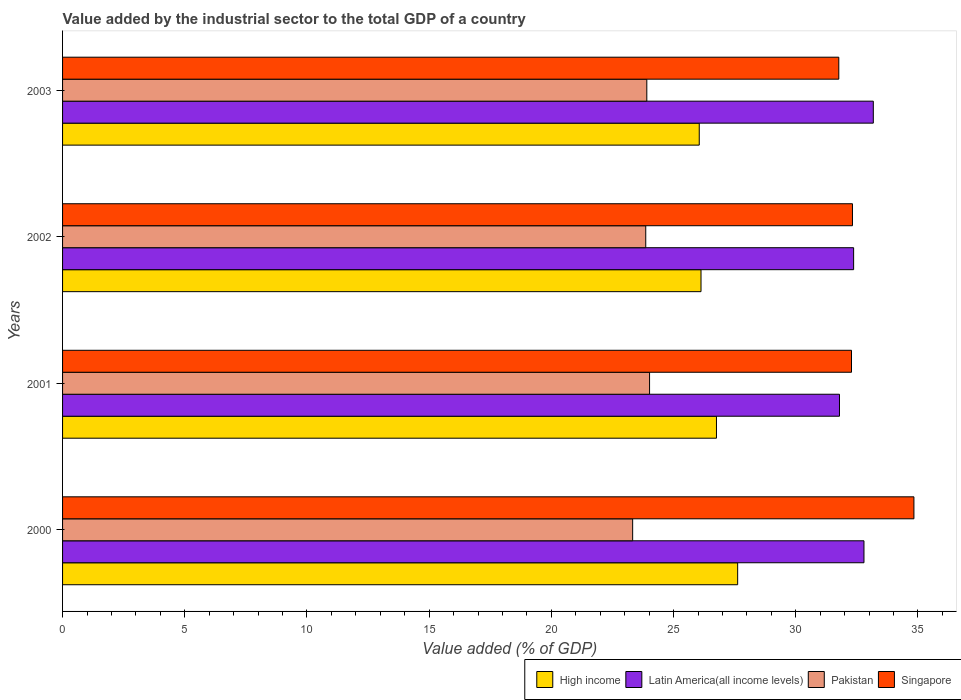How many different coloured bars are there?
Provide a short and direct response. 4. How many groups of bars are there?
Your answer should be compact. 4. Are the number of bars per tick equal to the number of legend labels?
Your answer should be compact. Yes. Are the number of bars on each tick of the Y-axis equal?
Provide a succinct answer. Yes. How many bars are there on the 4th tick from the top?
Offer a very short reply. 4. How many bars are there on the 3rd tick from the bottom?
Provide a short and direct response. 4. What is the label of the 2nd group of bars from the top?
Provide a succinct answer. 2002. What is the value added by the industrial sector to the total GDP in Latin America(all income levels) in 2002?
Ensure brevity in your answer.  32.37. Across all years, what is the maximum value added by the industrial sector to the total GDP in Pakistan?
Your answer should be compact. 24.02. Across all years, what is the minimum value added by the industrial sector to the total GDP in Latin America(all income levels)?
Your response must be concise. 31.79. In which year was the value added by the industrial sector to the total GDP in Singapore minimum?
Your answer should be very brief. 2003. What is the total value added by the industrial sector to the total GDP in Singapore in the graph?
Your answer should be very brief. 131.19. What is the difference between the value added by the industrial sector to the total GDP in Singapore in 2000 and that in 2003?
Make the answer very short. 3.07. What is the difference between the value added by the industrial sector to the total GDP in High income in 2000 and the value added by the industrial sector to the total GDP in Singapore in 2003?
Give a very brief answer. -4.14. What is the average value added by the industrial sector to the total GDP in Pakistan per year?
Give a very brief answer. 23.78. In the year 2003, what is the difference between the value added by the industrial sector to the total GDP in Singapore and value added by the industrial sector to the total GDP in Pakistan?
Your answer should be very brief. 7.86. What is the ratio of the value added by the industrial sector to the total GDP in Pakistan in 2000 to that in 2003?
Provide a short and direct response. 0.98. Is the difference between the value added by the industrial sector to the total GDP in Singapore in 2000 and 2002 greater than the difference between the value added by the industrial sector to the total GDP in Pakistan in 2000 and 2002?
Ensure brevity in your answer.  Yes. What is the difference between the highest and the second highest value added by the industrial sector to the total GDP in Pakistan?
Offer a terse response. 0.11. What is the difference between the highest and the lowest value added by the industrial sector to the total GDP in Singapore?
Your response must be concise. 3.07. Is the sum of the value added by the industrial sector to the total GDP in Pakistan in 2001 and 2002 greater than the maximum value added by the industrial sector to the total GDP in Latin America(all income levels) across all years?
Make the answer very short. Yes. What does the 2nd bar from the top in 2001 represents?
Provide a succinct answer. Pakistan. What does the 4th bar from the bottom in 2000 represents?
Ensure brevity in your answer.  Singapore. Is it the case that in every year, the sum of the value added by the industrial sector to the total GDP in Pakistan and value added by the industrial sector to the total GDP in High income is greater than the value added by the industrial sector to the total GDP in Singapore?
Provide a succinct answer. Yes. How many bars are there?
Ensure brevity in your answer.  16. Are all the bars in the graph horizontal?
Give a very brief answer. Yes. How many years are there in the graph?
Your response must be concise. 4. Where does the legend appear in the graph?
Your answer should be very brief. Bottom right. How many legend labels are there?
Offer a terse response. 4. What is the title of the graph?
Provide a short and direct response. Value added by the industrial sector to the total GDP of a country. Does "Austria" appear as one of the legend labels in the graph?
Offer a terse response. No. What is the label or title of the X-axis?
Provide a short and direct response. Value added (% of GDP). What is the Value added (% of GDP) in High income in 2000?
Offer a terse response. 27.62. What is the Value added (% of GDP) of Latin America(all income levels) in 2000?
Keep it short and to the point. 32.79. What is the Value added (% of GDP) of Pakistan in 2000?
Your response must be concise. 23.33. What is the Value added (% of GDP) of Singapore in 2000?
Ensure brevity in your answer.  34.83. What is the Value added (% of GDP) in High income in 2001?
Offer a terse response. 26.76. What is the Value added (% of GDP) in Latin America(all income levels) in 2001?
Offer a very short reply. 31.79. What is the Value added (% of GDP) of Pakistan in 2001?
Keep it short and to the point. 24.02. What is the Value added (% of GDP) of Singapore in 2001?
Provide a short and direct response. 32.28. What is the Value added (% of GDP) of High income in 2002?
Your answer should be compact. 26.12. What is the Value added (% of GDP) in Latin America(all income levels) in 2002?
Ensure brevity in your answer.  32.37. What is the Value added (% of GDP) in Pakistan in 2002?
Keep it short and to the point. 23.86. What is the Value added (% of GDP) of Singapore in 2002?
Your answer should be very brief. 32.32. What is the Value added (% of GDP) in High income in 2003?
Provide a short and direct response. 26.05. What is the Value added (% of GDP) in Latin America(all income levels) in 2003?
Your response must be concise. 33.17. What is the Value added (% of GDP) of Pakistan in 2003?
Give a very brief answer. 23.91. What is the Value added (% of GDP) of Singapore in 2003?
Your answer should be very brief. 31.76. Across all years, what is the maximum Value added (% of GDP) of High income?
Your response must be concise. 27.62. Across all years, what is the maximum Value added (% of GDP) of Latin America(all income levels)?
Your answer should be very brief. 33.17. Across all years, what is the maximum Value added (% of GDP) in Pakistan?
Provide a succinct answer. 24.02. Across all years, what is the maximum Value added (% of GDP) of Singapore?
Offer a terse response. 34.83. Across all years, what is the minimum Value added (% of GDP) in High income?
Keep it short and to the point. 26.05. Across all years, what is the minimum Value added (% of GDP) in Latin America(all income levels)?
Provide a succinct answer. 31.79. Across all years, what is the minimum Value added (% of GDP) of Pakistan?
Make the answer very short. 23.33. Across all years, what is the minimum Value added (% of GDP) in Singapore?
Your answer should be compact. 31.76. What is the total Value added (% of GDP) of High income in the graph?
Ensure brevity in your answer.  106.55. What is the total Value added (% of GDP) in Latin America(all income levels) in the graph?
Offer a terse response. 130.12. What is the total Value added (% of GDP) in Pakistan in the graph?
Make the answer very short. 95.11. What is the total Value added (% of GDP) of Singapore in the graph?
Offer a very short reply. 131.19. What is the difference between the Value added (% of GDP) of High income in 2000 and that in 2001?
Keep it short and to the point. 0.87. What is the difference between the Value added (% of GDP) of Pakistan in 2000 and that in 2001?
Your answer should be compact. -0.69. What is the difference between the Value added (% of GDP) in Singapore in 2000 and that in 2001?
Provide a succinct answer. 2.55. What is the difference between the Value added (% of GDP) of High income in 2000 and that in 2002?
Provide a short and direct response. 1.5. What is the difference between the Value added (% of GDP) of Latin America(all income levels) in 2000 and that in 2002?
Your answer should be very brief. 0.42. What is the difference between the Value added (% of GDP) of Pakistan in 2000 and that in 2002?
Provide a short and direct response. -0.54. What is the difference between the Value added (% of GDP) in Singapore in 2000 and that in 2002?
Ensure brevity in your answer.  2.51. What is the difference between the Value added (% of GDP) in High income in 2000 and that in 2003?
Keep it short and to the point. 1.57. What is the difference between the Value added (% of GDP) in Latin America(all income levels) in 2000 and that in 2003?
Your response must be concise. -0.38. What is the difference between the Value added (% of GDP) in Pakistan in 2000 and that in 2003?
Make the answer very short. -0.58. What is the difference between the Value added (% of GDP) in Singapore in 2000 and that in 2003?
Offer a terse response. 3.07. What is the difference between the Value added (% of GDP) of High income in 2001 and that in 2002?
Your answer should be compact. 0.63. What is the difference between the Value added (% of GDP) in Latin America(all income levels) in 2001 and that in 2002?
Give a very brief answer. -0.58. What is the difference between the Value added (% of GDP) in Pakistan in 2001 and that in 2002?
Your answer should be very brief. 0.16. What is the difference between the Value added (% of GDP) of Singapore in 2001 and that in 2002?
Your response must be concise. -0.04. What is the difference between the Value added (% of GDP) of High income in 2001 and that in 2003?
Offer a terse response. 0.7. What is the difference between the Value added (% of GDP) of Latin America(all income levels) in 2001 and that in 2003?
Ensure brevity in your answer.  -1.38. What is the difference between the Value added (% of GDP) of Pakistan in 2001 and that in 2003?
Your response must be concise. 0.11. What is the difference between the Value added (% of GDP) of Singapore in 2001 and that in 2003?
Offer a terse response. 0.52. What is the difference between the Value added (% of GDP) of High income in 2002 and that in 2003?
Provide a short and direct response. 0.07. What is the difference between the Value added (% of GDP) in Latin America(all income levels) in 2002 and that in 2003?
Make the answer very short. -0.81. What is the difference between the Value added (% of GDP) of Pakistan in 2002 and that in 2003?
Keep it short and to the point. -0.04. What is the difference between the Value added (% of GDP) of Singapore in 2002 and that in 2003?
Your answer should be very brief. 0.56. What is the difference between the Value added (% of GDP) in High income in 2000 and the Value added (% of GDP) in Latin America(all income levels) in 2001?
Offer a very short reply. -4.17. What is the difference between the Value added (% of GDP) in High income in 2000 and the Value added (% of GDP) in Pakistan in 2001?
Provide a succinct answer. 3.6. What is the difference between the Value added (% of GDP) in High income in 2000 and the Value added (% of GDP) in Singapore in 2001?
Your answer should be very brief. -4.66. What is the difference between the Value added (% of GDP) in Latin America(all income levels) in 2000 and the Value added (% of GDP) in Pakistan in 2001?
Give a very brief answer. 8.77. What is the difference between the Value added (% of GDP) of Latin America(all income levels) in 2000 and the Value added (% of GDP) of Singapore in 2001?
Provide a short and direct response. 0.51. What is the difference between the Value added (% of GDP) in Pakistan in 2000 and the Value added (% of GDP) in Singapore in 2001?
Your answer should be compact. -8.95. What is the difference between the Value added (% of GDP) in High income in 2000 and the Value added (% of GDP) in Latin America(all income levels) in 2002?
Your response must be concise. -4.75. What is the difference between the Value added (% of GDP) in High income in 2000 and the Value added (% of GDP) in Pakistan in 2002?
Offer a very short reply. 3.76. What is the difference between the Value added (% of GDP) in High income in 2000 and the Value added (% of GDP) in Singapore in 2002?
Provide a short and direct response. -4.7. What is the difference between the Value added (% of GDP) in Latin America(all income levels) in 2000 and the Value added (% of GDP) in Pakistan in 2002?
Ensure brevity in your answer.  8.93. What is the difference between the Value added (% of GDP) of Latin America(all income levels) in 2000 and the Value added (% of GDP) of Singapore in 2002?
Your answer should be compact. 0.47. What is the difference between the Value added (% of GDP) in Pakistan in 2000 and the Value added (% of GDP) in Singapore in 2002?
Offer a terse response. -8.99. What is the difference between the Value added (% of GDP) of High income in 2000 and the Value added (% of GDP) of Latin America(all income levels) in 2003?
Give a very brief answer. -5.55. What is the difference between the Value added (% of GDP) in High income in 2000 and the Value added (% of GDP) in Pakistan in 2003?
Offer a very short reply. 3.72. What is the difference between the Value added (% of GDP) of High income in 2000 and the Value added (% of GDP) of Singapore in 2003?
Your response must be concise. -4.14. What is the difference between the Value added (% of GDP) in Latin America(all income levels) in 2000 and the Value added (% of GDP) in Pakistan in 2003?
Your response must be concise. 8.88. What is the difference between the Value added (% of GDP) in Latin America(all income levels) in 2000 and the Value added (% of GDP) in Singapore in 2003?
Your answer should be compact. 1.03. What is the difference between the Value added (% of GDP) of Pakistan in 2000 and the Value added (% of GDP) of Singapore in 2003?
Offer a terse response. -8.43. What is the difference between the Value added (% of GDP) of High income in 2001 and the Value added (% of GDP) of Latin America(all income levels) in 2002?
Offer a terse response. -5.61. What is the difference between the Value added (% of GDP) of High income in 2001 and the Value added (% of GDP) of Pakistan in 2002?
Provide a succinct answer. 2.89. What is the difference between the Value added (% of GDP) of High income in 2001 and the Value added (% of GDP) of Singapore in 2002?
Make the answer very short. -5.56. What is the difference between the Value added (% of GDP) in Latin America(all income levels) in 2001 and the Value added (% of GDP) in Pakistan in 2002?
Offer a very short reply. 7.93. What is the difference between the Value added (% of GDP) in Latin America(all income levels) in 2001 and the Value added (% of GDP) in Singapore in 2002?
Keep it short and to the point. -0.53. What is the difference between the Value added (% of GDP) in Pakistan in 2001 and the Value added (% of GDP) in Singapore in 2002?
Provide a short and direct response. -8.3. What is the difference between the Value added (% of GDP) in High income in 2001 and the Value added (% of GDP) in Latin America(all income levels) in 2003?
Provide a succinct answer. -6.42. What is the difference between the Value added (% of GDP) in High income in 2001 and the Value added (% of GDP) in Pakistan in 2003?
Your answer should be very brief. 2.85. What is the difference between the Value added (% of GDP) of High income in 2001 and the Value added (% of GDP) of Singapore in 2003?
Give a very brief answer. -5.01. What is the difference between the Value added (% of GDP) in Latin America(all income levels) in 2001 and the Value added (% of GDP) in Pakistan in 2003?
Give a very brief answer. 7.88. What is the difference between the Value added (% of GDP) in Latin America(all income levels) in 2001 and the Value added (% of GDP) in Singapore in 2003?
Offer a terse response. 0.03. What is the difference between the Value added (% of GDP) of Pakistan in 2001 and the Value added (% of GDP) of Singapore in 2003?
Make the answer very short. -7.74. What is the difference between the Value added (% of GDP) of High income in 2002 and the Value added (% of GDP) of Latin America(all income levels) in 2003?
Make the answer very short. -7.05. What is the difference between the Value added (% of GDP) of High income in 2002 and the Value added (% of GDP) of Pakistan in 2003?
Offer a terse response. 2.22. What is the difference between the Value added (% of GDP) in High income in 2002 and the Value added (% of GDP) in Singapore in 2003?
Your answer should be very brief. -5.64. What is the difference between the Value added (% of GDP) of Latin America(all income levels) in 2002 and the Value added (% of GDP) of Pakistan in 2003?
Give a very brief answer. 8.46. What is the difference between the Value added (% of GDP) in Latin America(all income levels) in 2002 and the Value added (% of GDP) in Singapore in 2003?
Your answer should be very brief. 0.61. What is the difference between the Value added (% of GDP) in Pakistan in 2002 and the Value added (% of GDP) in Singapore in 2003?
Provide a short and direct response. -7.9. What is the average Value added (% of GDP) in High income per year?
Offer a terse response. 26.64. What is the average Value added (% of GDP) in Latin America(all income levels) per year?
Provide a short and direct response. 32.53. What is the average Value added (% of GDP) of Pakistan per year?
Offer a very short reply. 23.78. What is the average Value added (% of GDP) in Singapore per year?
Make the answer very short. 32.8. In the year 2000, what is the difference between the Value added (% of GDP) of High income and Value added (% of GDP) of Latin America(all income levels)?
Make the answer very short. -5.17. In the year 2000, what is the difference between the Value added (% of GDP) of High income and Value added (% of GDP) of Pakistan?
Ensure brevity in your answer.  4.3. In the year 2000, what is the difference between the Value added (% of GDP) in High income and Value added (% of GDP) in Singapore?
Provide a short and direct response. -7.21. In the year 2000, what is the difference between the Value added (% of GDP) in Latin America(all income levels) and Value added (% of GDP) in Pakistan?
Make the answer very short. 9.46. In the year 2000, what is the difference between the Value added (% of GDP) of Latin America(all income levels) and Value added (% of GDP) of Singapore?
Make the answer very short. -2.04. In the year 2000, what is the difference between the Value added (% of GDP) of Pakistan and Value added (% of GDP) of Singapore?
Keep it short and to the point. -11.51. In the year 2001, what is the difference between the Value added (% of GDP) of High income and Value added (% of GDP) of Latin America(all income levels)?
Provide a succinct answer. -5.03. In the year 2001, what is the difference between the Value added (% of GDP) of High income and Value added (% of GDP) of Pakistan?
Your answer should be compact. 2.74. In the year 2001, what is the difference between the Value added (% of GDP) in High income and Value added (% of GDP) in Singapore?
Your answer should be very brief. -5.52. In the year 2001, what is the difference between the Value added (% of GDP) of Latin America(all income levels) and Value added (% of GDP) of Pakistan?
Provide a succinct answer. 7.77. In the year 2001, what is the difference between the Value added (% of GDP) in Latin America(all income levels) and Value added (% of GDP) in Singapore?
Your response must be concise. -0.49. In the year 2001, what is the difference between the Value added (% of GDP) in Pakistan and Value added (% of GDP) in Singapore?
Your answer should be compact. -8.26. In the year 2002, what is the difference between the Value added (% of GDP) of High income and Value added (% of GDP) of Latin America(all income levels)?
Make the answer very short. -6.24. In the year 2002, what is the difference between the Value added (% of GDP) of High income and Value added (% of GDP) of Pakistan?
Give a very brief answer. 2.26. In the year 2002, what is the difference between the Value added (% of GDP) of High income and Value added (% of GDP) of Singapore?
Keep it short and to the point. -6.2. In the year 2002, what is the difference between the Value added (% of GDP) in Latin America(all income levels) and Value added (% of GDP) in Pakistan?
Your response must be concise. 8.51. In the year 2002, what is the difference between the Value added (% of GDP) in Latin America(all income levels) and Value added (% of GDP) in Singapore?
Your answer should be very brief. 0.05. In the year 2002, what is the difference between the Value added (% of GDP) of Pakistan and Value added (% of GDP) of Singapore?
Your answer should be very brief. -8.46. In the year 2003, what is the difference between the Value added (% of GDP) of High income and Value added (% of GDP) of Latin America(all income levels)?
Provide a succinct answer. -7.12. In the year 2003, what is the difference between the Value added (% of GDP) in High income and Value added (% of GDP) in Pakistan?
Give a very brief answer. 2.15. In the year 2003, what is the difference between the Value added (% of GDP) in High income and Value added (% of GDP) in Singapore?
Provide a short and direct response. -5.71. In the year 2003, what is the difference between the Value added (% of GDP) in Latin America(all income levels) and Value added (% of GDP) in Pakistan?
Your answer should be compact. 9.27. In the year 2003, what is the difference between the Value added (% of GDP) in Latin America(all income levels) and Value added (% of GDP) in Singapore?
Offer a very short reply. 1.41. In the year 2003, what is the difference between the Value added (% of GDP) of Pakistan and Value added (% of GDP) of Singapore?
Give a very brief answer. -7.86. What is the ratio of the Value added (% of GDP) in High income in 2000 to that in 2001?
Offer a terse response. 1.03. What is the ratio of the Value added (% of GDP) in Latin America(all income levels) in 2000 to that in 2001?
Keep it short and to the point. 1.03. What is the ratio of the Value added (% of GDP) in Pakistan in 2000 to that in 2001?
Offer a very short reply. 0.97. What is the ratio of the Value added (% of GDP) of Singapore in 2000 to that in 2001?
Offer a terse response. 1.08. What is the ratio of the Value added (% of GDP) of High income in 2000 to that in 2002?
Your answer should be compact. 1.06. What is the ratio of the Value added (% of GDP) of Latin America(all income levels) in 2000 to that in 2002?
Make the answer very short. 1.01. What is the ratio of the Value added (% of GDP) of Pakistan in 2000 to that in 2002?
Offer a terse response. 0.98. What is the ratio of the Value added (% of GDP) of Singapore in 2000 to that in 2002?
Your response must be concise. 1.08. What is the ratio of the Value added (% of GDP) in High income in 2000 to that in 2003?
Offer a very short reply. 1.06. What is the ratio of the Value added (% of GDP) of Latin America(all income levels) in 2000 to that in 2003?
Provide a short and direct response. 0.99. What is the ratio of the Value added (% of GDP) in Pakistan in 2000 to that in 2003?
Make the answer very short. 0.98. What is the ratio of the Value added (% of GDP) in Singapore in 2000 to that in 2003?
Your answer should be compact. 1.1. What is the ratio of the Value added (% of GDP) in High income in 2001 to that in 2002?
Make the answer very short. 1.02. What is the ratio of the Value added (% of GDP) of Latin America(all income levels) in 2001 to that in 2002?
Your answer should be compact. 0.98. What is the ratio of the Value added (% of GDP) in High income in 2001 to that in 2003?
Offer a very short reply. 1.03. What is the ratio of the Value added (% of GDP) in Singapore in 2001 to that in 2003?
Offer a terse response. 1.02. What is the ratio of the Value added (% of GDP) in Latin America(all income levels) in 2002 to that in 2003?
Your answer should be very brief. 0.98. What is the ratio of the Value added (% of GDP) of Pakistan in 2002 to that in 2003?
Your response must be concise. 1. What is the ratio of the Value added (% of GDP) of Singapore in 2002 to that in 2003?
Provide a short and direct response. 1.02. What is the difference between the highest and the second highest Value added (% of GDP) in High income?
Make the answer very short. 0.87. What is the difference between the highest and the second highest Value added (% of GDP) in Latin America(all income levels)?
Give a very brief answer. 0.38. What is the difference between the highest and the second highest Value added (% of GDP) of Pakistan?
Provide a succinct answer. 0.11. What is the difference between the highest and the second highest Value added (% of GDP) in Singapore?
Your answer should be very brief. 2.51. What is the difference between the highest and the lowest Value added (% of GDP) in High income?
Offer a terse response. 1.57. What is the difference between the highest and the lowest Value added (% of GDP) in Latin America(all income levels)?
Your answer should be very brief. 1.38. What is the difference between the highest and the lowest Value added (% of GDP) of Pakistan?
Make the answer very short. 0.69. What is the difference between the highest and the lowest Value added (% of GDP) of Singapore?
Your answer should be very brief. 3.07. 